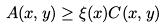<formula> <loc_0><loc_0><loc_500><loc_500>A ( x , y ) \geq \xi ( x ) C ( x , y )</formula> 